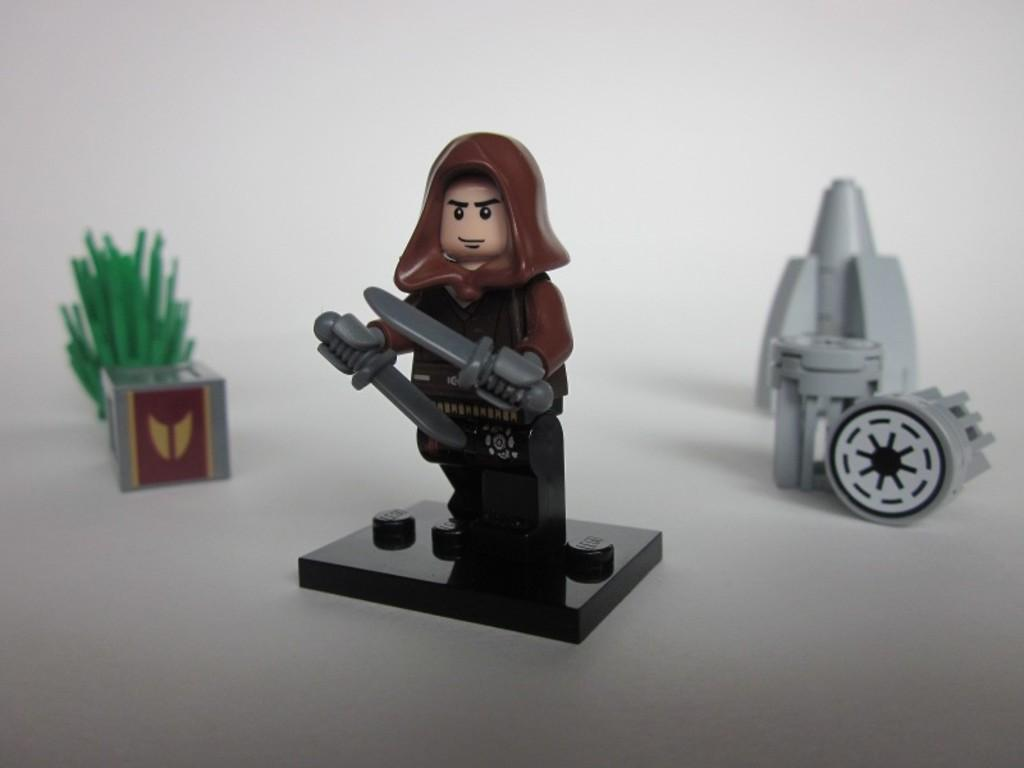What objects can be seen in the image? There are toys in the image. What color dominates the background of the image? The remaining portion of the image is in white color. Can you see the father wearing a veil in the image? There is no father or veil present in the image; it only features toys and a white background. 